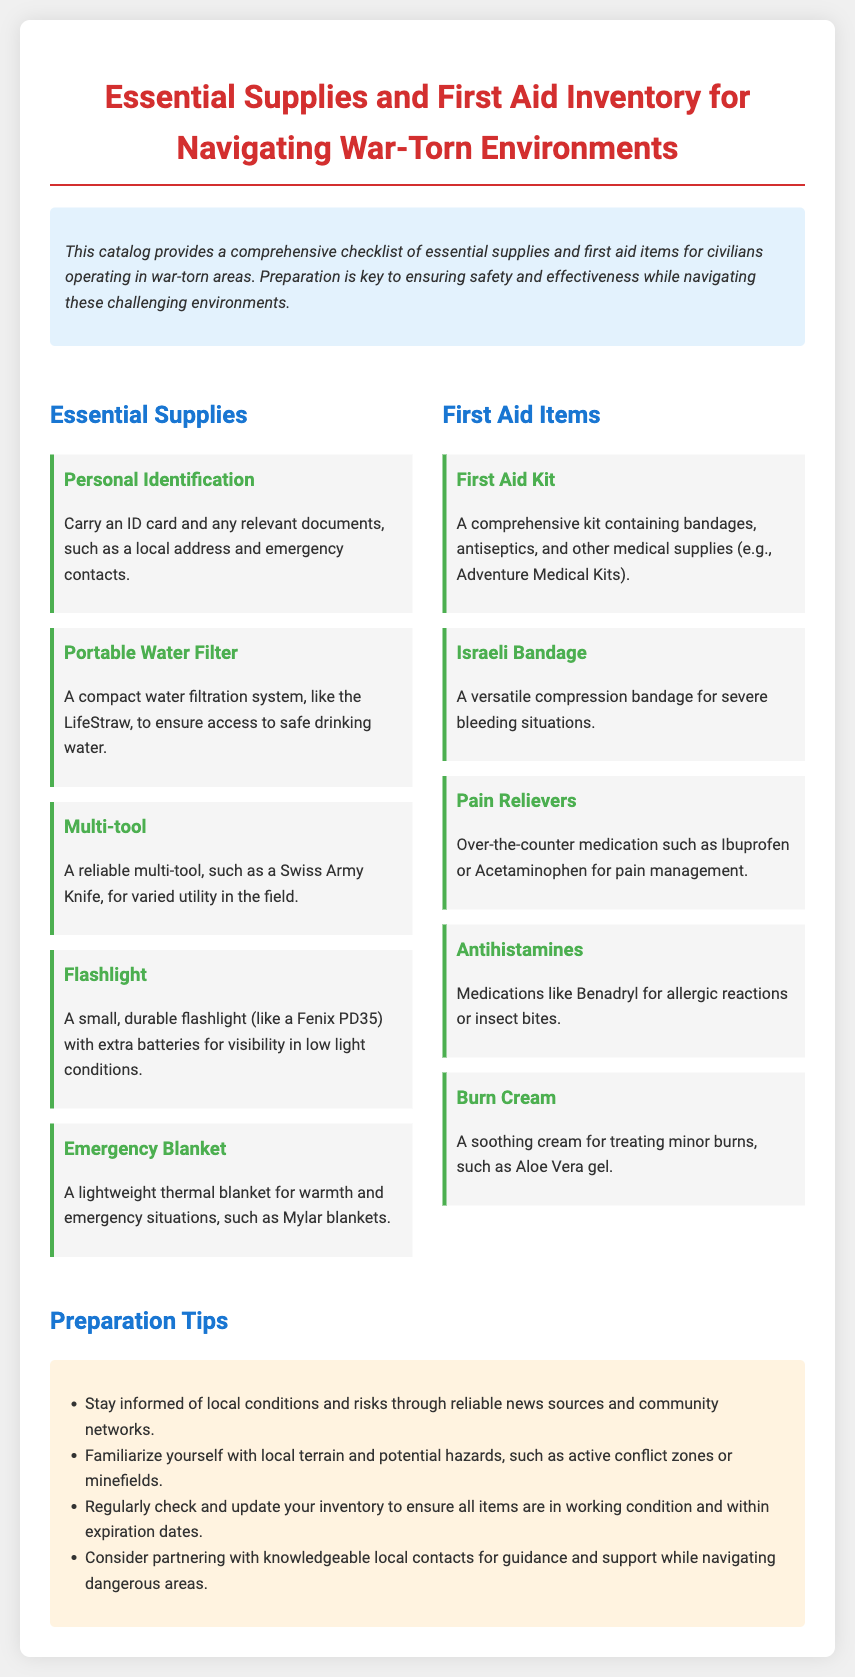What is the primary purpose of the catalog? The catalog provides a comprehensive checklist of essential supplies and first aid items for civilians operating in war-torn areas.
Answer: checklist of essential supplies Name one essential supply mentioned in the document. The document lists several essential supplies; one example is a Portable Water Filter.
Answer: Portable Water Filter How many first aid items are listed in the document? The document contains a total of five first aid items listed under the First Aid Items section.
Answer: five What is one preparation tip provided in the document? One preparation tip suggests staying informed of local conditions and risks through reliable news sources and community networks.
Answer: stay informed Which item is recommended for treating burns? The document mentions Burn Cream as a recommended item for treating burns.
Answer: Burn Cream 